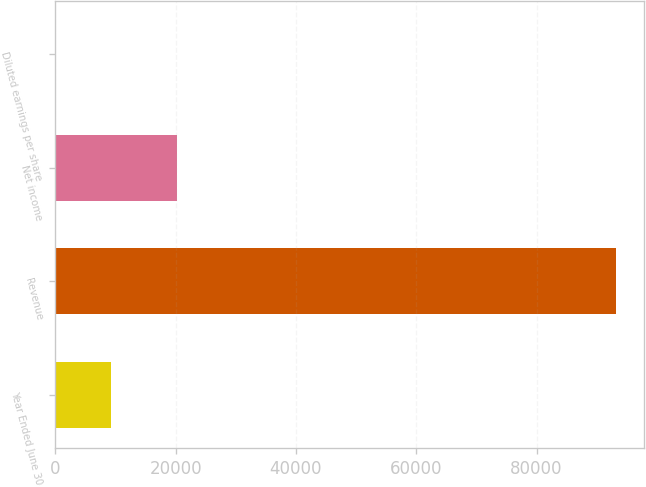Convert chart to OTSL. <chart><loc_0><loc_0><loc_500><loc_500><bar_chart><fcel>Year Ended June 30<fcel>Revenue<fcel>Net income<fcel>Diluted earnings per share<nl><fcel>9326.44<fcel>93243<fcel>20153<fcel>2.38<nl></chart> 